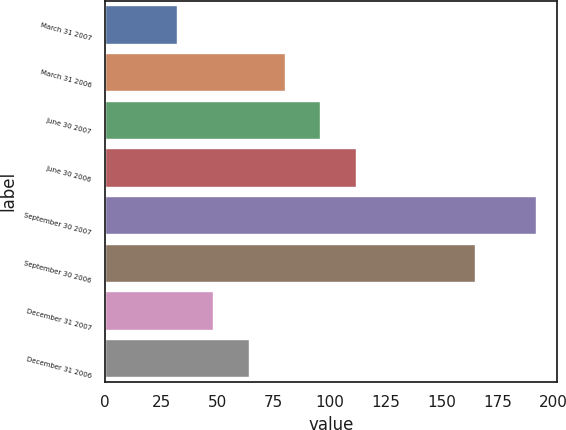Convert chart. <chart><loc_0><loc_0><loc_500><loc_500><bar_chart><fcel>March 31 2007<fcel>March 31 2006<fcel>June 30 2007<fcel>June 30 2006<fcel>September 30 2007<fcel>September 30 2006<fcel>December 31 2007<fcel>December 31 2006<nl><fcel>32<fcel>80<fcel>96<fcel>112<fcel>192<fcel>165<fcel>48<fcel>64<nl></chart> 